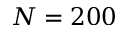<formula> <loc_0><loc_0><loc_500><loc_500>N = 2 0 0</formula> 